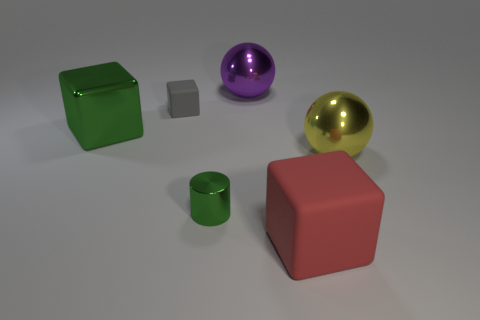Subtract all matte cubes. How many cubes are left? 1 Add 1 big green metal balls. How many objects exist? 7 Subtract all balls. How many objects are left? 4 Subtract all shiny things. Subtract all green cubes. How many objects are left? 1 Add 2 small green cylinders. How many small green cylinders are left? 3 Add 1 shiny cubes. How many shiny cubes exist? 2 Subtract 1 green cubes. How many objects are left? 5 